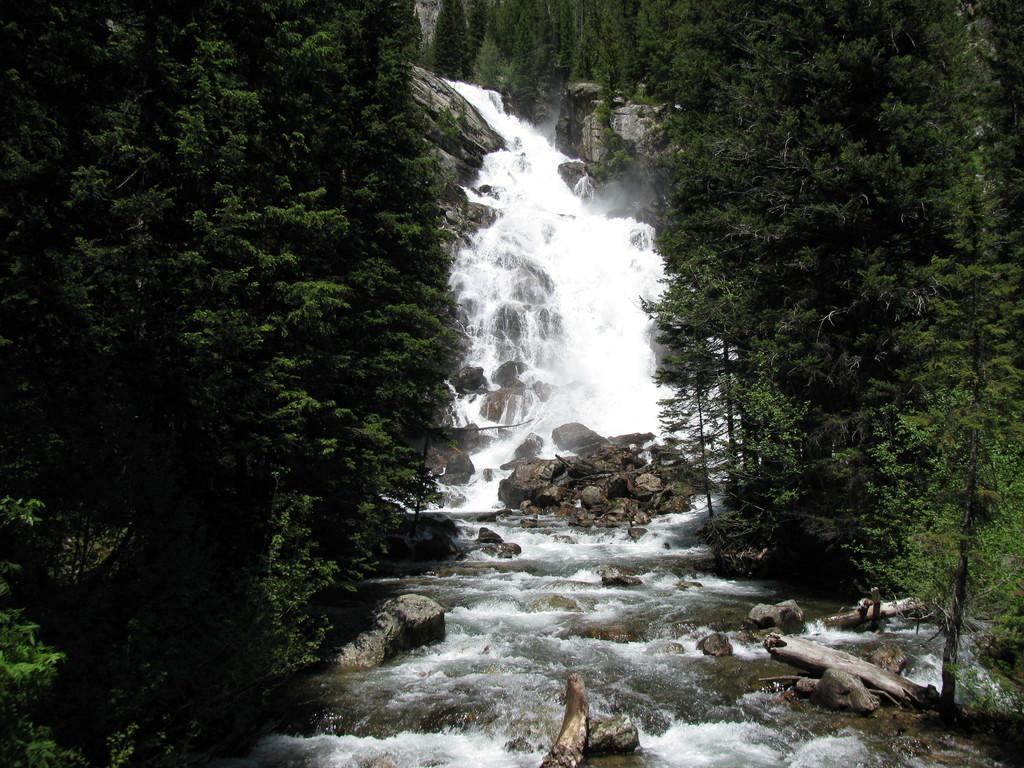Can you describe this image briefly? This is an outside view. In the middle of the image I can see the waterfalls and there are some rocks. On the right and left side of the image there are many trees. 